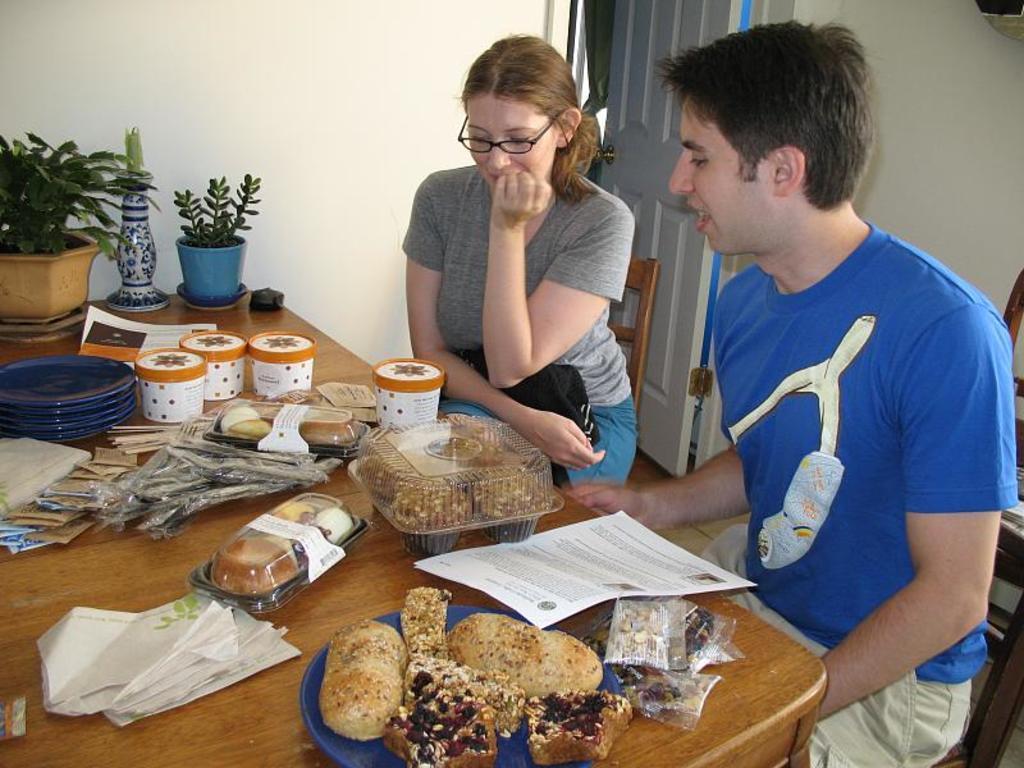Please provide a concise description of this image. Here in picture we can see two persons. On the right side there is man wearing blue shirt and he is talking. To the right of him there is a lady. In front of them there is a table. On that table there is a paper, cookies box. There are some cups and blue color plates, flowerpot, tissues and some food items in the plate. 